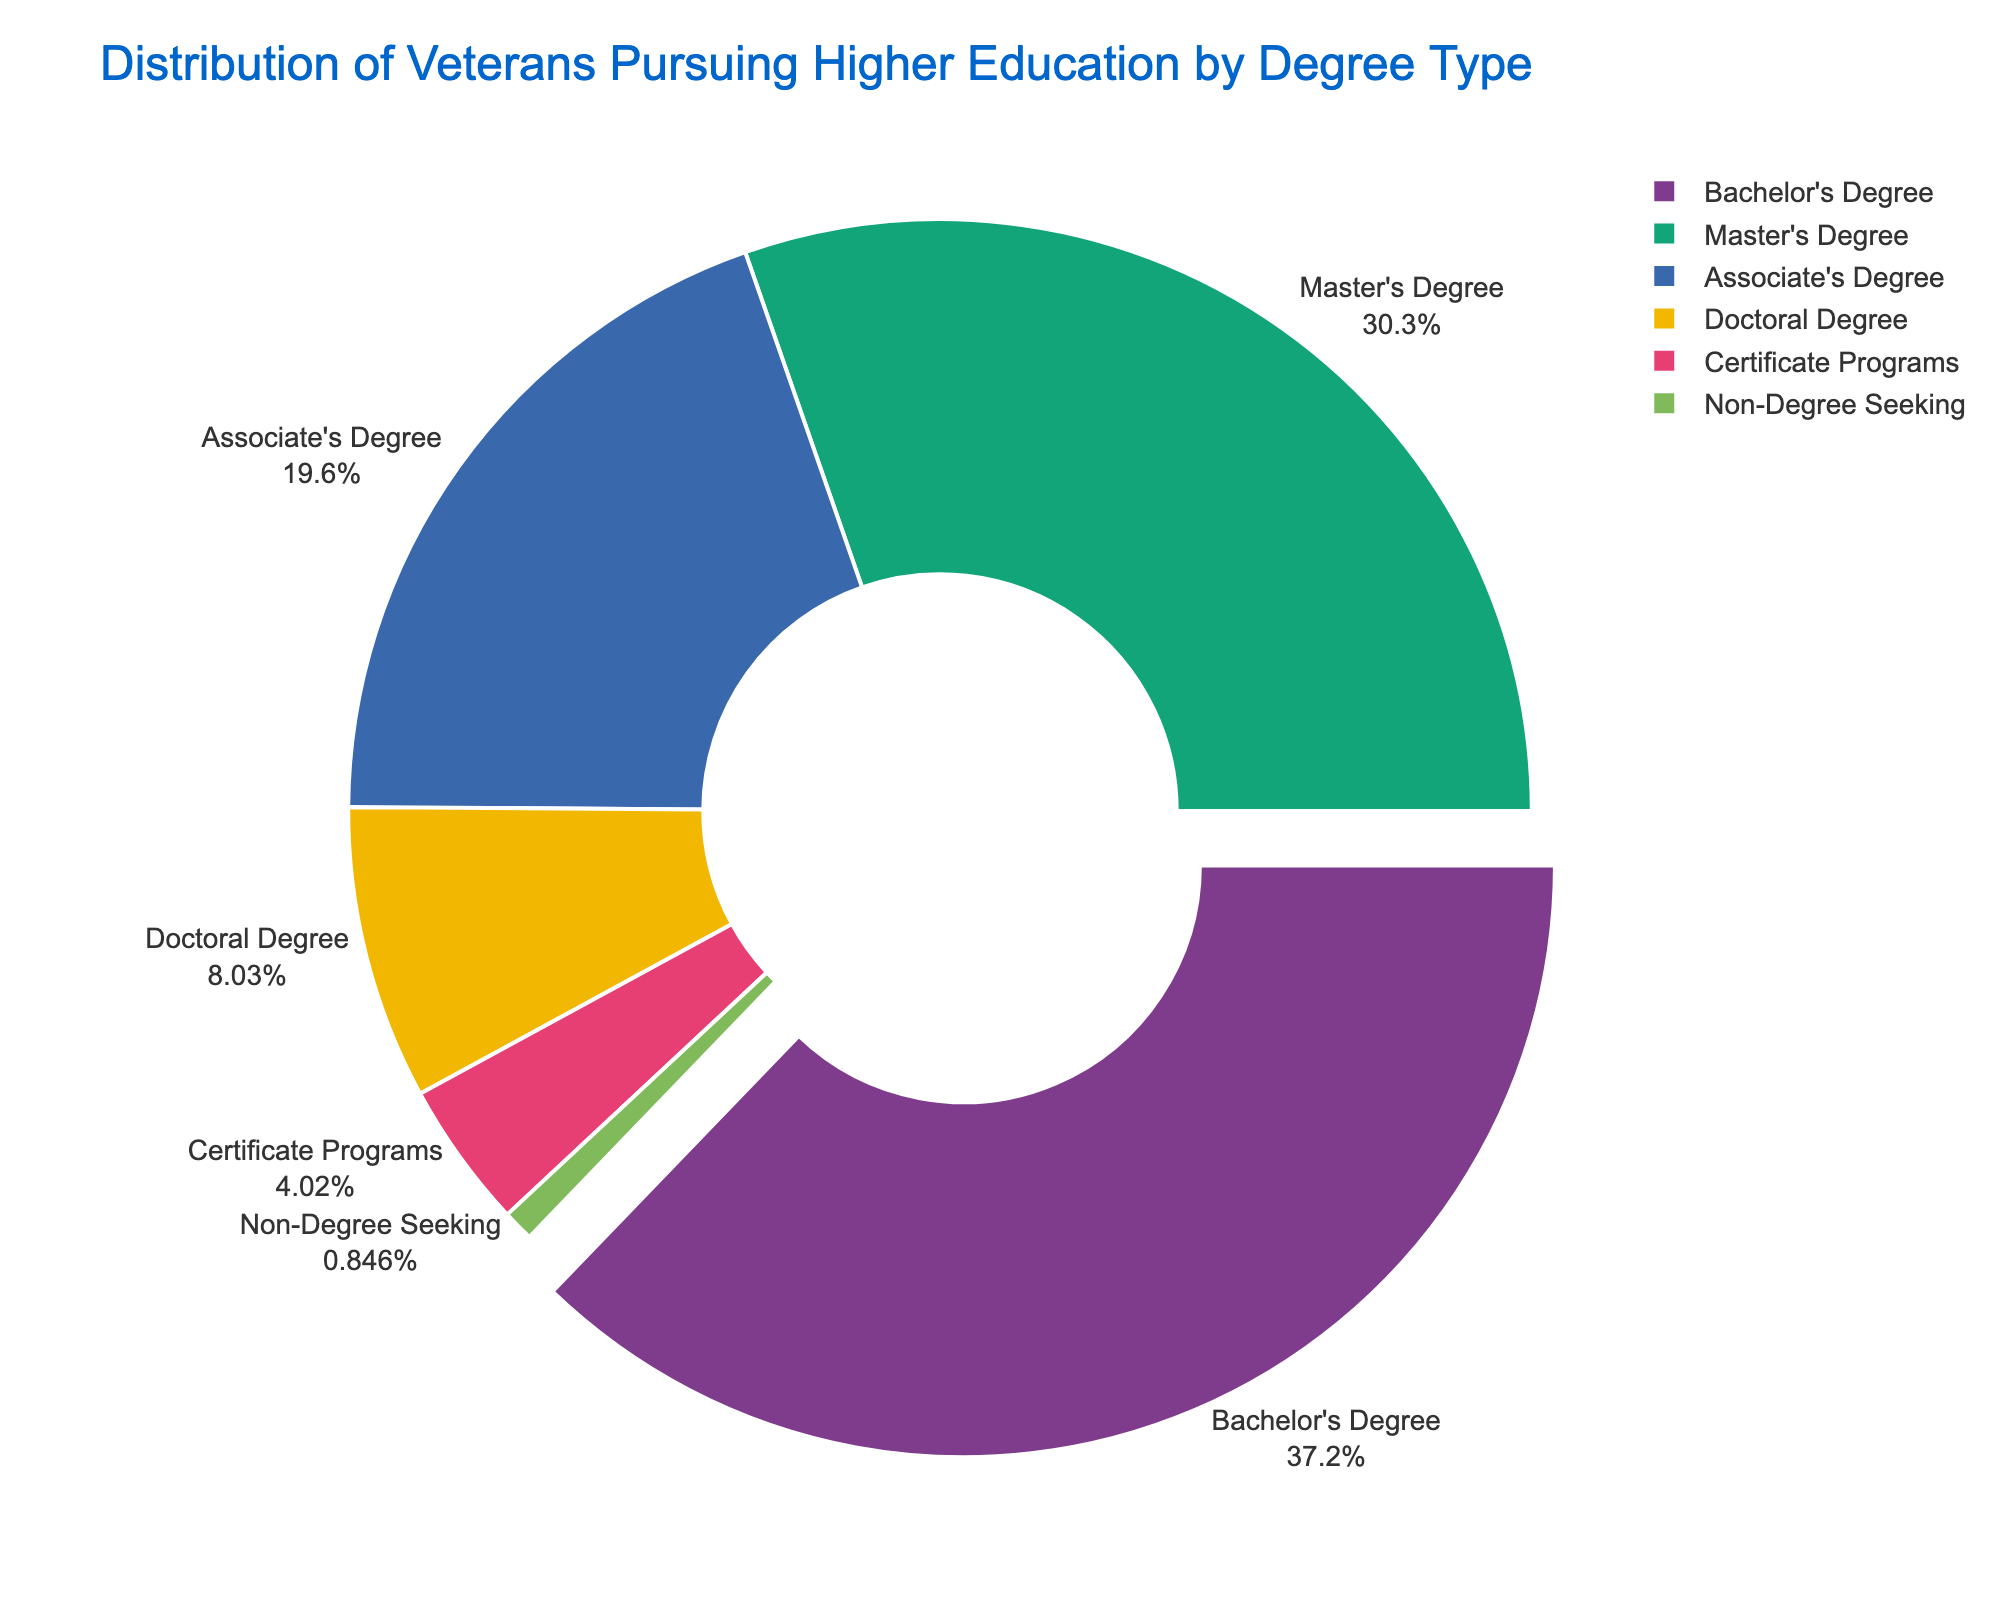What's the degree type with the highest percentage of veterans pursuing higher education? The pie chart shows different slices representing various degree types. The slice with the largest size, prominently pulled out, indicates the degree type with the highest percentage. In this case, it's labeled "Bachelor's Degree" at 35.2%.
Answer: Bachelor's Degree Which degree types are pursued by less than 10% of veterans? To determine this, we need to look at the slices of the pie chart and identify which ones have labels indicating percentages less than 10%. The smaller slices with percentages of 7.6%, 3.8%, and 0.8% correspond to Doctoral Degree, Certificate Programs, and Non-Degree Seeking respectively.
Answer: Doctoral Degree, Certificate Programs, Non-Degree Seeking What is the combined percentage of veterans pursuing Associate's and Master's Degrees? Add the percentages for Associate's Degree and Master's Degree. The pie chart shows that the percentage for Associate's Degree is 18.5% and for Master's Degree is 28.7%. Summing these gives 18.5 + 28.7 = 47.2%.
Answer: 47.2% Compare the percentage of veterans pursuing Doctoral Degrees and Certificate Programs. Which is higher and by how much? The pie chart shows that the percentage for Doctoral Degree is 7.6% and for Certificate Programs is 3.8%. To find which is higher, we subtract the smaller percentage from the larger one: 7.6 - 3.8 = 3.8%. The Doctoral Degree percentage is higher by 3.8%.
Answer: Doctoral Degree by 3.8% What fraction of veterans are pursuing Bachelor's Degrees? The pie chart shows that 35.2% of veterans are pursuing Bachelor's Degrees. To convert this percentage to a fraction, we divide it by 100: 35.2 / 100 = 0.352. Thus, the fraction is 352/1000, which simplifies to 176/500 or 88/250 or 44/125.
Answer: 44/125 How does the percentage of veterans pursuing Non-Degree Seeking compare to those pursuing an Associate's Degree? The pie chart shows that the percentage for Non-Degree Seeking is 0.8% and for Associate's Degree it is 18.5%. To compare, subtract the smaller percentage from the larger: 18.5 - 0.8 = 17.7%. Thus, Associate's Degree has a 17.7% higher proportion.
Answer: 17.7% higher What's the average percentage of veterans pursuing Master's, Doctoral, and Certificate Programs? To find the average percentage, sum the percentages for Master's Degree (28.7%), Doctoral Degree (7.6%), and Certificate Programs (3.8%), then divide by the number of categories. (28.7 + 7.6 + 3.8) / 3 = 40.1 / 3 = 13.37%.
Answer: 13.37% What's the difference in percentage points between the highest and lowest degree types pursued by veterans? The pie chart shows the highest percentage is for Bachelor's Degree at 35.2% and the lowest is for Non-Degree Seeking at 0.8%. Subtract the lowest from the highest: 35.2 - 0.8 = 34.4 percentage points.
Answer: 34.4 percentage points 